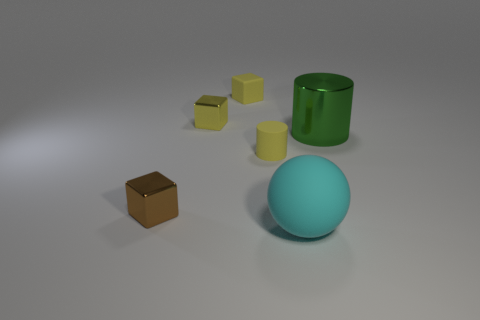Are there any small yellow things of the same shape as the large green metallic object?
Offer a very short reply. Yes. What number of other objects are there of the same shape as the yellow metallic thing?
Keep it short and to the point. 2. What shape is the object that is both on the right side of the yellow rubber cylinder and on the left side of the shiny cylinder?
Your response must be concise. Sphere. What size is the cylinder to the left of the cyan object?
Offer a very short reply. Small. Does the cyan ball have the same size as the yellow cylinder?
Offer a very short reply. No. Is the number of tiny yellow rubber blocks that are left of the tiny rubber cube less than the number of yellow things in front of the cyan matte sphere?
Offer a very short reply. No. What is the size of the shiny thing that is behind the brown thing and to the left of the tiny yellow cylinder?
Give a very brief answer. Small. There is a thing that is to the right of the large object that is in front of the tiny yellow rubber cylinder; is there a yellow matte block that is in front of it?
Give a very brief answer. No. Is there a red rubber ball?
Your response must be concise. No. Are there more tiny metallic things behind the tiny matte cylinder than large rubber balls that are on the right side of the big rubber ball?
Provide a short and direct response. Yes. 